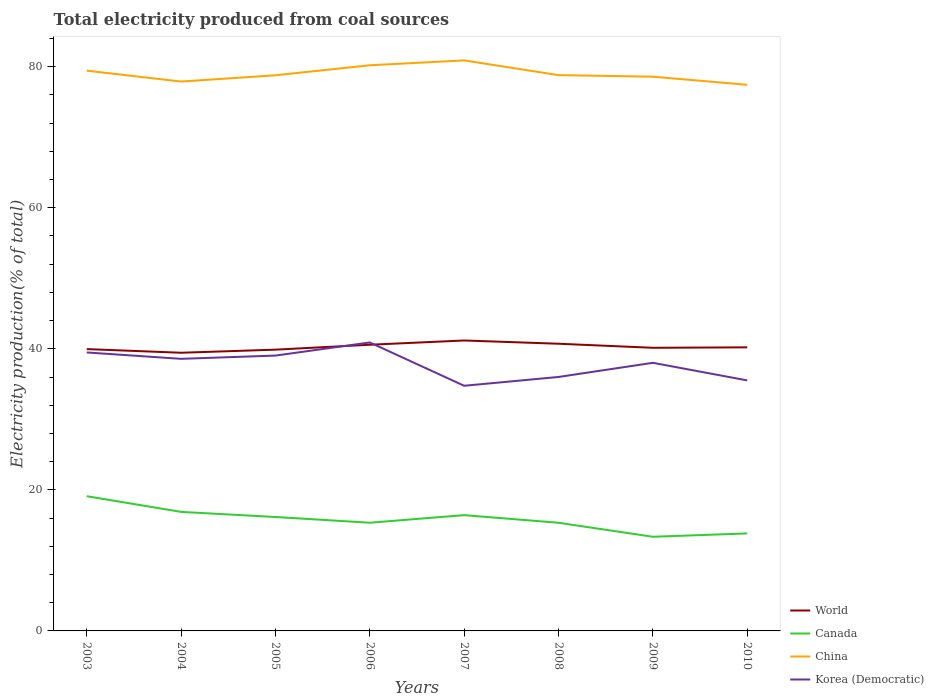Does the line corresponding to Korea (Democratic) intersect with the line corresponding to China?
Give a very brief answer. No. Is the number of lines equal to the number of legend labels?
Offer a terse response. Yes. Across all years, what is the maximum total electricity produced in China?
Your answer should be very brief. 77.44. In which year was the total electricity produced in Canada maximum?
Your answer should be very brief. 2009. What is the total total electricity produced in Canada in the graph?
Keep it short and to the point. 2.8. What is the difference between the highest and the second highest total electricity produced in Canada?
Provide a succinct answer. 5.75. What is the difference between the highest and the lowest total electricity produced in World?
Keep it short and to the point. 3. Is the total electricity produced in Korea (Democratic) strictly greater than the total electricity produced in World over the years?
Keep it short and to the point. No. How many years are there in the graph?
Your answer should be very brief. 8. Does the graph contain grids?
Your answer should be compact. No. What is the title of the graph?
Your answer should be compact. Total electricity produced from coal sources. Does "Uganda" appear as one of the legend labels in the graph?
Give a very brief answer. No. What is the label or title of the X-axis?
Your answer should be very brief. Years. What is the Electricity production(% of total) in World in 2003?
Keep it short and to the point. 39.96. What is the Electricity production(% of total) in Canada in 2003?
Give a very brief answer. 19.11. What is the Electricity production(% of total) of China in 2003?
Make the answer very short. 79.44. What is the Electricity production(% of total) in Korea (Democratic) in 2003?
Give a very brief answer. 39.49. What is the Electricity production(% of total) of World in 2004?
Your answer should be compact. 39.44. What is the Electricity production(% of total) in Canada in 2004?
Provide a succinct answer. 16.88. What is the Electricity production(% of total) of China in 2004?
Make the answer very short. 77.9. What is the Electricity production(% of total) of Korea (Democratic) in 2004?
Give a very brief answer. 38.58. What is the Electricity production(% of total) of World in 2005?
Keep it short and to the point. 39.88. What is the Electricity production(% of total) of Canada in 2005?
Give a very brief answer. 16.15. What is the Electricity production(% of total) of China in 2005?
Your response must be concise. 78.79. What is the Electricity production(% of total) in Korea (Democratic) in 2005?
Offer a terse response. 39.04. What is the Electricity production(% of total) in World in 2006?
Provide a short and direct response. 40.58. What is the Electricity production(% of total) of Canada in 2006?
Provide a succinct answer. 15.34. What is the Electricity production(% of total) in China in 2006?
Make the answer very short. 80.21. What is the Electricity production(% of total) in Korea (Democratic) in 2006?
Provide a short and direct response. 40.9. What is the Electricity production(% of total) of World in 2007?
Your response must be concise. 41.18. What is the Electricity production(% of total) of Canada in 2007?
Keep it short and to the point. 16.42. What is the Electricity production(% of total) of China in 2007?
Your answer should be very brief. 80.9. What is the Electricity production(% of total) of Korea (Democratic) in 2007?
Keep it short and to the point. 34.76. What is the Electricity production(% of total) in World in 2008?
Make the answer very short. 40.72. What is the Electricity production(% of total) in Canada in 2008?
Your response must be concise. 15.34. What is the Electricity production(% of total) in China in 2008?
Your answer should be very brief. 78.81. What is the Electricity production(% of total) in Korea (Democratic) in 2008?
Offer a terse response. 36.01. What is the Electricity production(% of total) of World in 2009?
Provide a short and direct response. 40.15. What is the Electricity production(% of total) of Canada in 2009?
Your answer should be compact. 13.35. What is the Electricity production(% of total) in China in 2009?
Make the answer very short. 78.59. What is the Electricity production(% of total) in Korea (Democratic) in 2009?
Your answer should be very brief. 38.02. What is the Electricity production(% of total) of World in 2010?
Keep it short and to the point. 40.21. What is the Electricity production(% of total) of Canada in 2010?
Keep it short and to the point. 13.83. What is the Electricity production(% of total) of China in 2010?
Keep it short and to the point. 77.44. What is the Electricity production(% of total) of Korea (Democratic) in 2010?
Offer a terse response. 35.52. Across all years, what is the maximum Electricity production(% of total) in World?
Provide a short and direct response. 41.18. Across all years, what is the maximum Electricity production(% of total) in Canada?
Offer a terse response. 19.11. Across all years, what is the maximum Electricity production(% of total) in China?
Make the answer very short. 80.9. Across all years, what is the maximum Electricity production(% of total) of Korea (Democratic)?
Offer a terse response. 40.9. Across all years, what is the minimum Electricity production(% of total) of World?
Offer a terse response. 39.44. Across all years, what is the minimum Electricity production(% of total) in Canada?
Your answer should be compact. 13.35. Across all years, what is the minimum Electricity production(% of total) of China?
Ensure brevity in your answer.  77.44. Across all years, what is the minimum Electricity production(% of total) in Korea (Democratic)?
Make the answer very short. 34.76. What is the total Electricity production(% of total) in World in the graph?
Your answer should be compact. 322.14. What is the total Electricity production(% of total) of Canada in the graph?
Provide a succinct answer. 126.41. What is the total Electricity production(% of total) of China in the graph?
Your answer should be compact. 632.09. What is the total Electricity production(% of total) in Korea (Democratic) in the graph?
Your answer should be very brief. 302.33. What is the difference between the Electricity production(% of total) of World in 2003 and that in 2004?
Give a very brief answer. 0.52. What is the difference between the Electricity production(% of total) in Canada in 2003 and that in 2004?
Offer a very short reply. 2.23. What is the difference between the Electricity production(% of total) in China in 2003 and that in 2004?
Give a very brief answer. 1.54. What is the difference between the Electricity production(% of total) in Korea (Democratic) in 2003 and that in 2004?
Provide a short and direct response. 0.91. What is the difference between the Electricity production(% of total) of World in 2003 and that in 2005?
Your answer should be compact. 0.08. What is the difference between the Electricity production(% of total) of Canada in 2003 and that in 2005?
Ensure brevity in your answer.  2.95. What is the difference between the Electricity production(% of total) in China in 2003 and that in 2005?
Ensure brevity in your answer.  0.65. What is the difference between the Electricity production(% of total) of Korea (Democratic) in 2003 and that in 2005?
Make the answer very short. 0.44. What is the difference between the Electricity production(% of total) in World in 2003 and that in 2006?
Offer a terse response. -0.62. What is the difference between the Electricity production(% of total) in Canada in 2003 and that in 2006?
Offer a terse response. 3.76. What is the difference between the Electricity production(% of total) of China in 2003 and that in 2006?
Provide a succinct answer. -0.77. What is the difference between the Electricity production(% of total) in Korea (Democratic) in 2003 and that in 2006?
Give a very brief answer. -1.42. What is the difference between the Electricity production(% of total) of World in 2003 and that in 2007?
Your answer should be very brief. -1.22. What is the difference between the Electricity production(% of total) of Canada in 2003 and that in 2007?
Keep it short and to the point. 2.69. What is the difference between the Electricity production(% of total) in China in 2003 and that in 2007?
Offer a terse response. -1.46. What is the difference between the Electricity production(% of total) in Korea (Democratic) in 2003 and that in 2007?
Make the answer very short. 4.72. What is the difference between the Electricity production(% of total) in World in 2003 and that in 2008?
Your response must be concise. -0.76. What is the difference between the Electricity production(% of total) in Canada in 2003 and that in 2008?
Keep it short and to the point. 3.77. What is the difference between the Electricity production(% of total) of China in 2003 and that in 2008?
Make the answer very short. 0.63. What is the difference between the Electricity production(% of total) in Korea (Democratic) in 2003 and that in 2008?
Offer a very short reply. 3.48. What is the difference between the Electricity production(% of total) of World in 2003 and that in 2009?
Provide a short and direct response. -0.19. What is the difference between the Electricity production(% of total) in Canada in 2003 and that in 2009?
Make the answer very short. 5.75. What is the difference between the Electricity production(% of total) of China in 2003 and that in 2009?
Ensure brevity in your answer.  0.85. What is the difference between the Electricity production(% of total) in Korea (Democratic) in 2003 and that in 2009?
Make the answer very short. 1.47. What is the difference between the Electricity production(% of total) in World in 2003 and that in 2010?
Give a very brief answer. -0.25. What is the difference between the Electricity production(% of total) of Canada in 2003 and that in 2010?
Ensure brevity in your answer.  5.28. What is the difference between the Electricity production(% of total) of China in 2003 and that in 2010?
Ensure brevity in your answer.  2. What is the difference between the Electricity production(% of total) of Korea (Democratic) in 2003 and that in 2010?
Give a very brief answer. 3.96. What is the difference between the Electricity production(% of total) in World in 2004 and that in 2005?
Ensure brevity in your answer.  -0.44. What is the difference between the Electricity production(% of total) of Canada in 2004 and that in 2005?
Your answer should be very brief. 0.73. What is the difference between the Electricity production(% of total) of China in 2004 and that in 2005?
Provide a succinct answer. -0.89. What is the difference between the Electricity production(% of total) of Korea (Democratic) in 2004 and that in 2005?
Your response must be concise. -0.46. What is the difference between the Electricity production(% of total) in World in 2004 and that in 2006?
Provide a succinct answer. -1.14. What is the difference between the Electricity production(% of total) of Canada in 2004 and that in 2006?
Offer a terse response. 1.54. What is the difference between the Electricity production(% of total) in China in 2004 and that in 2006?
Your answer should be compact. -2.31. What is the difference between the Electricity production(% of total) of Korea (Democratic) in 2004 and that in 2006?
Make the answer very short. -2.32. What is the difference between the Electricity production(% of total) in World in 2004 and that in 2007?
Ensure brevity in your answer.  -1.74. What is the difference between the Electricity production(% of total) in Canada in 2004 and that in 2007?
Make the answer very short. 0.46. What is the difference between the Electricity production(% of total) in China in 2004 and that in 2007?
Your answer should be very brief. -3. What is the difference between the Electricity production(% of total) in Korea (Democratic) in 2004 and that in 2007?
Offer a very short reply. 3.82. What is the difference between the Electricity production(% of total) of World in 2004 and that in 2008?
Offer a very short reply. -1.28. What is the difference between the Electricity production(% of total) in Canada in 2004 and that in 2008?
Your answer should be very brief. 1.54. What is the difference between the Electricity production(% of total) of China in 2004 and that in 2008?
Your response must be concise. -0.91. What is the difference between the Electricity production(% of total) in Korea (Democratic) in 2004 and that in 2008?
Offer a very short reply. 2.57. What is the difference between the Electricity production(% of total) in World in 2004 and that in 2009?
Give a very brief answer. -0.7. What is the difference between the Electricity production(% of total) of Canada in 2004 and that in 2009?
Provide a succinct answer. 3.53. What is the difference between the Electricity production(% of total) of China in 2004 and that in 2009?
Your answer should be compact. -0.69. What is the difference between the Electricity production(% of total) in Korea (Democratic) in 2004 and that in 2009?
Your response must be concise. 0.56. What is the difference between the Electricity production(% of total) of World in 2004 and that in 2010?
Offer a very short reply. -0.77. What is the difference between the Electricity production(% of total) of Canada in 2004 and that in 2010?
Give a very brief answer. 3.05. What is the difference between the Electricity production(% of total) of China in 2004 and that in 2010?
Your response must be concise. 0.46. What is the difference between the Electricity production(% of total) in Korea (Democratic) in 2004 and that in 2010?
Your answer should be very brief. 3.06. What is the difference between the Electricity production(% of total) in World in 2005 and that in 2006?
Your response must be concise. -0.7. What is the difference between the Electricity production(% of total) in Canada in 2005 and that in 2006?
Your answer should be compact. 0.81. What is the difference between the Electricity production(% of total) of China in 2005 and that in 2006?
Ensure brevity in your answer.  -1.42. What is the difference between the Electricity production(% of total) in Korea (Democratic) in 2005 and that in 2006?
Offer a very short reply. -1.86. What is the difference between the Electricity production(% of total) in World in 2005 and that in 2007?
Provide a short and direct response. -1.3. What is the difference between the Electricity production(% of total) of Canada in 2005 and that in 2007?
Your answer should be compact. -0.26. What is the difference between the Electricity production(% of total) in China in 2005 and that in 2007?
Give a very brief answer. -2.11. What is the difference between the Electricity production(% of total) of Korea (Democratic) in 2005 and that in 2007?
Make the answer very short. 4.28. What is the difference between the Electricity production(% of total) of World in 2005 and that in 2008?
Make the answer very short. -0.84. What is the difference between the Electricity production(% of total) in Canada in 2005 and that in 2008?
Offer a terse response. 0.82. What is the difference between the Electricity production(% of total) in China in 2005 and that in 2008?
Give a very brief answer. -0.02. What is the difference between the Electricity production(% of total) in Korea (Democratic) in 2005 and that in 2008?
Your answer should be very brief. 3.03. What is the difference between the Electricity production(% of total) of World in 2005 and that in 2009?
Offer a very short reply. -0.26. What is the difference between the Electricity production(% of total) in Canada in 2005 and that in 2009?
Your answer should be very brief. 2.8. What is the difference between the Electricity production(% of total) of China in 2005 and that in 2009?
Ensure brevity in your answer.  0.2. What is the difference between the Electricity production(% of total) in Korea (Democratic) in 2005 and that in 2009?
Your answer should be very brief. 1.02. What is the difference between the Electricity production(% of total) of World in 2005 and that in 2010?
Provide a succinct answer. -0.33. What is the difference between the Electricity production(% of total) in Canada in 2005 and that in 2010?
Ensure brevity in your answer.  2.33. What is the difference between the Electricity production(% of total) in China in 2005 and that in 2010?
Ensure brevity in your answer.  1.35. What is the difference between the Electricity production(% of total) in Korea (Democratic) in 2005 and that in 2010?
Provide a short and direct response. 3.52. What is the difference between the Electricity production(% of total) in World in 2006 and that in 2007?
Keep it short and to the point. -0.6. What is the difference between the Electricity production(% of total) of Canada in 2006 and that in 2007?
Keep it short and to the point. -1.07. What is the difference between the Electricity production(% of total) in China in 2006 and that in 2007?
Offer a terse response. -0.69. What is the difference between the Electricity production(% of total) of Korea (Democratic) in 2006 and that in 2007?
Your response must be concise. 6.14. What is the difference between the Electricity production(% of total) of World in 2006 and that in 2008?
Your answer should be very brief. -0.14. What is the difference between the Electricity production(% of total) in Canada in 2006 and that in 2008?
Offer a terse response. 0.01. What is the difference between the Electricity production(% of total) of China in 2006 and that in 2008?
Provide a succinct answer. 1.4. What is the difference between the Electricity production(% of total) in Korea (Democratic) in 2006 and that in 2008?
Your answer should be compact. 4.89. What is the difference between the Electricity production(% of total) in World in 2006 and that in 2009?
Keep it short and to the point. 0.43. What is the difference between the Electricity production(% of total) in Canada in 2006 and that in 2009?
Ensure brevity in your answer.  1.99. What is the difference between the Electricity production(% of total) of China in 2006 and that in 2009?
Give a very brief answer. 1.62. What is the difference between the Electricity production(% of total) in Korea (Democratic) in 2006 and that in 2009?
Keep it short and to the point. 2.88. What is the difference between the Electricity production(% of total) in World in 2006 and that in 2010?
Your response must be concise. 0.37. What is the difference between the Electricity production(% of total) in Canada in 2006 and that in 2010?
Keep it short and to the point. 1.52. What is the difference between the Electricity production(% of total) of China in 2006 and that in 2010?
Your answer should be very brief. 2.77. What is the difference between the Electricity production(% of total) in Korea (Democratic) in 2006 and that in 2010?
Ensure brevity in your answer.  5.38. What is the difference between the Electricity production(% of total) of World in 2007 and that in 2008?
Your answer should be compact. 0.46. What is the difference between the Electricity production(% of total) of Canada in 2007 and that in 2008?
Your answer should be very brief. 1.08. What is the difference between the Electricity production(% of total) in China in 2007 and that in 2008?
Offer a terse response. 2.09. What is the difference between the Electricity production(% of total) of Korea (Democratic) in 2007 and that in 2008?
Make the answer very short. -1.25. What is the difference between the Electricity production(% of total) of World in 2007 and that in 2009?
Provide a succinct answer. 1.04. What is the difference between the Electricity production(% of total) of Canada in 2007 and that in 2009?
Your answer should be very brief. 3.07. What is the difference between the Electricity production(% of total) of China in 2007 and that in 2009?
Offer a very short reply. 2.31. What is the difference between the Electricity production(% of total) in Korea (Democratic) in 2007 and that in 2009?
Offer a terse response. -3.26. What is the difference between the Electricity production(% of total) of World in 2007 and that in 2010?
Keep it short and to the point. 0.97. What is the difference between the Electricity production(% of total) of Canada in 2007 and that in 2010?
Offer a terse response. 2.59. What is the difference between the Electricity production(% of total) in China in 2007 and that in 2010?
Provide a succinct answer. 3.46. What is the difference between the Electricity production(% of total) of Korea (Democratic) in 2007 and that in 2010?
Ensure brevity in your answer.  -0.76. What is the difference between the Electricity production(% of total) in World in 2008 and that in 2009?
Give a very brief answer. 0.58. What is the difference between the Electricity production(% of total) in Canada in 2008 and that in 2009?
Your answer should be very brief. 1.99. What is the difference between the Electricity production(% of total) in China in 2008 and that in 2009?
Keep it short and to the point. 0.22. What is the difference between the Electricity production(% of total) in Korea (Democratic) in 2008 and that in 2009?
Keep it short and to the point. -2.01. What is the difference between the Electricity production(% of total) in World in 2008 and that in 2010?
Your answer should be compact. 0.51. What is the difference between the Electricity production(% of total) in Canada in 2008 and that in 2010?
Offer a very short reply. 1.51. What is the difference between the Electricity production(% of total) of China in 2008 and that in 2010?
Give a very brief answer. 1.37. What is the difference between the Electricity production(% of total) in Korea (Democratic) in 2008 and that in 2010?
Your response must be concise. 0.49. What is the difference between the Electricity production(% of total) of World in 2009 and that in 2010?
Offer a terse response. -0.06. What is the difference between the Electricity production(% of total) of Canada in 2009 and that in 2010?
Offer a very short reply. -0.47. What is the difference between the Electricity production(% of total) of China in 2009 and that in 2010?
Ensure brevity in your answer.  1.15. What is the difference between the Electricity production(% of total) of Korea (Democratic) in 2009 and that in 2010?
Provide a short and direct response. 2.5. What is the difference between the Electricity production(% of total) in World in 2003 and the Electricity production(% of total) in Canada in 2004?
Provide a short and direct response. 23.08. What is the difference between the Electricity production(% of total) of World in 2003 and the Electricity production(% of total) of China in 2004?
Make the answer very short. -37.94. What is the difference between the Electricity production(% of total) of World in 2003 and the Electricity production(% of total) of Korea (Democratic) in 2004?
Your answer should be compact. 1.38. What is the difference between the Electricity production(% of total) in Canada in 2003 and the Electricity production(% of total) in China in 2004?
Make the answer very short. -58.79. What is the difference between the Electricity production(% of total) of Canada in 2003 and the Electricity production(% of total) of Korea (Democratic) in 2004?
Your response must be concise. -19.48. What is the difference between the Electricity production(% of total) of China in 2003 and the Electricity production(% of total) of Korea (Democratic) in 2004?
Offer a terse response. 40.86. What is the difference between the Electricity production(% of total) of World in 2003 and the Electricity production(% of total) of Canada in 2005?
Keep it short and to the point. 23.81. What is the difference between the Electricity production(% of total) of World in 2003 and the Electricity production(% of total) of China in 2005?
Give a very brief answer. -38.83. What is the difference between the Electricity production(% of total) of World in 2003 and the Electricity production(% of total) of Korea (Democratic) in 2005?
Your answer should be very brief. 0.92. What is the difference between the Electricity production(% of total) of Canada in 2003 and the Electricity production(% of total) of China in 2005?
Give a very brief answer. -59.69. What is the difference between the Electricity production(% of total) in Canada in 2003 and the Electricity production(% of total) in Korea (Democratic) in 2005?
Offer a terse response. -19.94. What is the difference between the Electricity production(% of total) of China in 2003 and the Electricity production(% of total) of Korea (Democratic) in 2005?
Provide a succinct answer. 40.4. What is the difference between the Electricity production(% of total) of World in 2003 and the Electricity production(% of total) of Canada in 2006?
Ensure brevity in your answer.  24.62. What is the difference between the Electricity production(% of total) of World in 2003 and the Electricity production(% of total) of China in 2006?
Make the answer very short. -40.25. What is the difference between the Electricity production(% of total) in World in 2003 and the Electricity production(% of total) in Korea (Democratic) in 2006?
Your answer should be compact. -0.94. What is the difference between the Electricity production(% of total) in Canada in 2003 and the Electricity production(% of total) in China in 2006?
Give a very brief answer. -61.11. What is the difference between the Electricity production(% of total) of Canada in 2003 and the Electricity production(% of total) of Korea (Democratic) in 2006?
Your answer should be very brief. -21.8. What is the difference between the Electricity production(% of total) in China in 2003 and the Electricity production(% of total) in Korea (Democratic) in 2006?
Ensure brevity in your answer.  38.54. What is the difference between the Electricity production(% of total) in World in 2003 and the Electricity production(% of total) in Canada in 2007?
Provide a succinct answer. 23.55. What is the difference between the Electricity production(% of total) of World in 2003 and the Electricity production(% of total) of China in 2007?
Make the answer very short. -40.94. What is the difference between the Electricity production(% of total) in World in 2003 and the Electricity production(% of total) in Korea (Democratic) in 2007?
Keep it short and to the point. 5.2. What is the difference between the Electricity production(% of total) in Canada in 2003 and the Electricity production(% of total) in China in 2007?
Your answer should be very brief. -61.8. What is the difference between the Electricity production(% of total) of Canada in 2003 and the Electricity production(% of total) of Korea (Democratic) in 2007?
Your answer should be compact. -15.66. What is the difference between the Electricity production(% of total) of China in 2003 and the Electricity production(% of total) of Korea (Democratic) in 2007?
Your answer should be compact. 44.68. What is the difference between the Electricity production(% of total) in World in 2003 and the Electricity production(% of total) in Canada in 2008?
Your answer should be very brief. 24.63. What is the difference between the Electricity production(% of total) of World in 2003 and the Electricity production(% of total) of China in 2008?
Your response must be concise. -38.85. What is the difference between the Electricity production(% of total) in World in 2003 and the Electricity production(% of total) in Korea (Democratic) in 2008?
Provide a short and direct response. 3.95. What is the difference between the Electricity production(% of total) in Canada in 2003 and the Electricity production(% of total) in China in 2008?
Offer a terse response. -59.7. What is the difference between the Electricity production(% of total) in Canada in 2003 and the Electricity production(% of total) in Korea (Democratic) in 2008?
Give a very brief answer. -16.91. What is the difference between the Electricity production(% of total) in China in 2003 and the Electricity production(% of total) in Korea (Democratic) in 2008?
Give a very brief answer. 43.43. What is the difference between the Electricity production(% of total) of World in 2003 and the Electricity production(% of total) of Canada in 2009?
Provide a succinct answer. 26.61. What is the difference between the Electricity production(% of total) in World in 2003 and the Electricity production(% of total) in China in 2009?
Ensure brevity in your answer.  -38.63. What is the difference between the Electricity production(% of total) in World in 2003 and the Electricity production(% of total) in Korea (Democratic) in 2009?
Make the answer very short. 1.94. What is the difference between the Electricity production(% of total) in Canada in 2003 and the Electricity production(% of total) in China in 2009?
Your answer should be compact. -59.49. What is the difference between the Electricity production(% of total) in Canada in 2003 and the Electricity production(% of total) in Korea (Democratic) in 2009?
Offer a terse response. -18.91. What is the difference between the Electricity production(% of total) in China in 2003 and the Electricity production(% of total) in Korea (Democratic) in 2009?
Your answer should be very brief. 41.42. What is the difference between the Electricity production(% of total) in World in 2003 and the Electricity production(% of total) in Canada in 2010?
Offer a very short reply. 26.14. What is the difference between the Electricity production(% of total) of World in 2003 and the Electricity production(% of total) of China in 2010?
Offer a terse response. -37.48. What is the difference between the Electricity production(% of total) in World in 2003 and the Electricity production(% of total) in Korea (Democratic) in 2010?
Ensure brevity in your answer.  4.44. What is the difference between the Electricity production(% of total) of Canada in 2003 and the Electricity production(% of total) of China in 2010?
Keep it short and to the point. -58.33. What is the difference between the Electricity production(% of total) in Canada in 2003 and the Electricity production(% of total) in Korea (Democratic) in 2010?
Provide a succinct answer. -16.42. What is the difference between the Electricity production(% of total) of China in 2003 and the Electricity production(% of total) of Korea (Democratic) in 2010?
Keep it short and to the point. 43.92. What is the difference between the Electricity production(% of total) of World in 2004 and the Electricity production(% of total) of Canada in 2005?
Provide a succinct answer. 23.29. What is the difference between the Electricity production(% of total) of World in 2004 and the Electricity production(% of total) of China in 2005?
Give a very brief answer. -39.35. What is the difference between the Electricity production(% of total) of World in 2004 and the Electricity production(% of total) of Korea (Democratic) in 2005?
Your answer should be very brief. 0.4. What is the difference between the Electricity production(% of total) in Canada in 2004 and the Electricity production(% of total) in China in 2005?
Provide a short and direct response. -61.91. What is the difference between the Electricity production(% of total) of Canada in 2004 and the Electricity production(% of total) of Korea (Democratic) in 2005?
Offer a terse response. -22.16. What is the difference between the Electricity production(% of total) of China in 2004 and the Electricity production(% of total) of Korea (Democratic) in 2005?
Your response must be concise. 38.86. What is the difference between the Electricity production(% of total) of World in 2004 and the Electricity production(% of total) of Canada in 2006?
Offer a very short reply. 24.1. What is the difference between the Electricity production(% of total) in World in 2004 and the Electricity production(% of total) in China in 2006?
Your response must be concise. -40.77. What is the difference between the Electricity production(% of total) in World in 2004 and the Electricity production(% of total) in Korea (Democratic) in 2006?
Make the answer very short. -1.46. What is the difference between the Electricity production(% of total) of Canada in 2004 and the Electricity production(% of total) of China in 2006?
Your answer should be compact. -63.33. What is the difference between the Electricity production(% of total) in Canada in 2004 and the Electricity production(% of total) in Korea (Democratic) in 2006?
Your response must be concise. -24.02. What is the difference between the Electricity production(% of total) of China in 2004 and the Electricity production(% of total) of Korea (Democratic) in 2006?
Provide a succinct answer. 37. What is the difference between the Electricity production(% of total) of World in 2004 and the Electricity production(% of total) of Canada in 2007?
Provide a short and direct response. 23.03. What is the difference between the Electricity production(% of total) of World in 2004 and the Electricity production(% of total) of China in 2007?
Make the answer very short. -41.46. What is the difference between the Electricity production(% of total) in World in 2004 and the Electricity production(% of total) in Korea (Democratic) in 2007?
Offer a very short reply. 4.68. What is the difference between the Electricity production(% of total) of Canada in 2004 and the Electricity production(% of total) of China in 2007?
Ensure brevity in your answer.  -64.02. What is the difference between the Electricity production(% of total) in Canada in 2004 and the Electricity production(% of total) in Korea (Democratic) in 2007?
Your response must be concise. -17.88. What is the difference between the Electricity production(% of total) of China in 2004 and the Electricity production(% of total) of Korea (Democratic) in 2007?
Your response must be concise. 43.14. What is the difference between the Electricity production(% of total) of World in 2004 and the Electricity production(% of total) of Canada in 2008?
Keep it short and to the point. 24.11. What is the difference between the Electricity production(% of total) of World in 2004 and the Electricity production(% of total) of China in 2008?
Keep it short and to the point. -39.37. What is the difference between the Electricity production(% of total) of World in 2004 and the Electricity production(% of total) of Korea (Democratic) in 2008?
Keep it short and to the point. 3.43. What is the difference between the Electricity production(% of total) of Canada in 2004 and the Electricity production(% of total) of China in 2008?
Your response must be concise. -61.93. What is the difference between the Electricity production(% of total) of Canada in 2004 and the Electricity production(% of total) of Korea (Democratic) in 2008?
Ensure brevity in your answer.  -19.13. What is the difference between the Electricity production(% of total) in China in 2004 and the Electricity production(% of total) in Korea (Democratic) in 2008?
Your response must be concise. 41.89. What is the difference between the Electricity production(% of total) in World in 2004 and the Electricity production(% of total) in Canada in 2009?
Provide a short and direct response. 26.09. What is the difference between the Electricity production(% of total) in World in 2004 and the Electricity production(% of total) in China in 2009?
Offer a terse response. -39.15. What is the difference between the Electricity production(% of total) of World in 2004 and the Electricity production(% of total) of Korea (Democratic) in 2009?
Your answer should be very brief. 1.43. What is the difference between the Electricity production(% of total) in Canada in 2004 and the Electricity production(% of total) in China in 2009?
Keep it short and to the point. -61.71. What is the difference between the Electricity production(% of total) in Canada in 2004 and the Electricity production(% of total) in Korea (Democratic) in 2009?
Your answer should be compact. -21.14. What is the difference between the Electricity production(% of total) of China in 2004 and the Electricity production(% of total) of Korea (Democratic) in 2009?
Your response must be concise. 39.88. What is the difference between the Electricity production(% of total) in World in 2004 and the Electricity production(% of total) in Canada in 2010?
Your answer should be very brief. 25.62. What is the difference between the Electricity production(% of total) of World in 2004 and the Electricity production(% of total) of China in 2010?
Your response must be concise. -38. What is the difference between the Electricity production(% of total) in World in 2004 and the Electricity production(% of total) in Korea (Democratic) in 2010?
Ensure brevity in your answer.  3.92. What is the difference between the Electricity production(% of total) in Canada in 2004 and the Electricity production(% of total) in China in 2010?
Offer a terse response. -60.56. What is the difference between the Electricity production(% of total) of Canada in 2004 and the Electricity production(% of total) of Korea (Democratic) in 2010?
Offer a very short reply. -18.64. What is the difference between the Electricity production(% of total) of China in 2004 and the Electricity production(% of total) of Korea (Democratic) in 2010?
Provide a short and direct response. 42.38. What is the difference between the Electricity production(% of total) of World in 2005 and the Electricity production(% of total) of Canada in 2006?
Your answer should be very brief. 24.54. What is the difference between the Electricity production(% of total) of World in 2005 and the Electricity production(% of total) of China in 2006?
Offer a very short reply. -40.33. What is the difference between the Electricity production(% of total) in World in 2005 and the Electricity production(% of total) in Korea (Democratic) in 2006?
Provide a short and direct response. -1.02. What is the difference between the Electricity production(% of total) in Canada in 2005 and the Electricity production(% of total) in China in 2006?
Provide a succinct answer. -64.06. What is the difference between the Electricity production(% of total) in Canada in 2005 and the Electricity production(% of total) in Korea (Democratic) in 2006?
Your response must be concise. -24.75. What is the difference between the Electricity production(% of total) in China in 2005 and the Electricity production(% of total) in Korea (Democratic) in 2006?
Make the answer very short. 37.89. What is the difference between the Electricity production(% of total) of World in 2005 and the Electricity production(% of total) of Canada in 2007?
Offer a terse response. 23.47. What is the difference between the Electricity production(% of total) in World in 2005 and the Electricity production(% of total) in China in 2007?
Ensure brevity in your answer.  -41.02. What is the difference between the Electricity production(% of total) in World in 2005 and the Electricity production(% of total) in Korea (Democratic) in 2007?
Make the answer very short. 5.12. What is the difference between the Electricity production(% of total) of Canada in 2005 and the Electricity production(% of total) of China in 2007?
Make the answer very short. -64.75. What is the difference between the Electricity production(% of total) in Canada in 2005 and the Electricity production(% of total) in Korea (Democratic) in 2007?
Offer a very short reply. -18.61. What is the difference between the Electricity production(% of total) in China in 2005 and the Electricity production(% of total) in Korea (Democratic) in 2007?
Ensure brevity in your answer.  44.03. What is the difference between the Electricity production(% of total) in World in 2005 and the Electricity production(% of total) in Canada in 2008?
Give a very brief answer. 24.55. What is the difference between the Electricity production(% of total) of World in 2005 and the Electricity production(% of total) of China in 2008?
Make the answer very short. -38.93. What is the difference between the Electricity production(% of total) in World in 2005 and the Electricity production(% of total) in Korea (Democratic) in 2008?
Offer a terse response. 3.87. What is the difference between the Electricity production(% of total) of Canada in 2005 and the Electricity production(% of total) of China in 2008?
Provide a short and direct response. -62.66. What is the difference between the Electricity production(% of total) of Canada in 2005 and the Electricity production(% of total) of Korea (Democratic) in 2008?
Offer a terse response. -19.86. What is the difference between the Electricity production(% of total) in China in 2005 and the Electricity production(% of total) in Korea (Democratic) in 2008?
Keep it short and to the point. 42.78. What is the difference between the Electricity production(% of total) of World in 2005 and the Electricity production(% of total) of Canada in 2009?
Provide a short and direct response. 26.53. What is the difference between the Electricity production(% of total) in World in 2005 and the Electricity production(% of total) in China in 2009?
Ensure brevity in your answer.  -38.71. What is the difference between the Electricity production(% of total) of World in 2005 and the Electricity production(% of total) of Korea (Democratic) in 2009?
Provide a short and direct response. 1.87. What is the difference between the Electricity production(% of total) of Canada in 2005 and the Electricity production(% of total) of China in 2009?
Offer a terse response. -62.44. What is the difference between the Electricity production(% of total) in Canada in 2005 and the Electricity production(% of total) in Korea (Democratic) in 2009?
Your answer should be very brief. -21.87. What is the difference between the Electricity production(% of total) in China in 2005 and the Electricity production(% of total) in Korea (Democratic) in 2009?
Provide a succinct answer. 40.77. What is the difference between the Electricity production(% of total) in World in 2005 and the Electricity production(% of total) in Canada in 2010?
Make the answer very short. 26.06. What is the difference between the Electricity production(% of total) in World in 2005 and the Electricity production(% of total) in China in 2010?
Make the answer very short. -37.56. What is the difference between the Electricity production(% of total) of World in 2005 and the Electricity production(% of total) of Korea (Democratic) in 2010?
Provide a short and direct response. 4.36. What is the difference between the Electricity production(% of total) of Canada in 2005 and the Electricity production(% of total) of China in 2010?
Offer a terse response. -61.29. What is the difference between the Electricity production(% of total) in Canada in 2005 and the Electricity production(% of total) in Korea (Democratic) in 2010?
Ensure brevity in your answer.  -19.37. What is the difference between the Electricity production(% of total) in China in 2005 and the Electricity production(% of total) in Korea (Democratic) in 2010?
Your response must be concise. 43.27. What is the difference between the Electricity production(% of total) in World in 2006 and the Electricity production(% of total) in Canada in 2007?
Your answer should be compact. 24.16. What is the difference between the Electricity production(% of total) of World in 2006 and the Electricity production(% of total) of China in 2007?
Make the answer very short. -40.32. What is the difference between the Electricity production(% of total) of World in 2006 and the Electricity production(% of total) of Korea (Democratic) in 2007?
Keep it short and to the point. 5.82. What is the difference between the Electricity production(% of total) of Canada in 2006 and the Electricity production(% of total) of China in 2007?
Provide a short and direct response. -65.56. What is the difference between the Electricity production(% of total) of Canada in 2006 and the Electricity production(% of total) of Korea (Democratic) in 2007?
Keep it short and to the point. -19.42. What is the difference between the Electricity production(% of total) in China in 2006 and the Electricity production(% of total) in Korea (Democratic) in 2007?
Your answer should be very brief. 45.45. What is the difference between the Electricity production(% of total) in World in 2006 and the Electricity production(% of total) in Canada in 2008?
Keep it short and to the point. 25.24. What is the difference between the Electricity production(% of total) of World in 2006 and the Electricity production(% of total) of China in 2008?
Provide a short and direct response. -38.23. What is the difference between the Electricity production(% of total) of World in 2006 and the Electricity production(% of total) of Korea (Democratic) in 2008?
Offer a very short reply. 4.57. What is the difference between the Electricity production(% of total) of Canada in 2006 and the Electricity production(% of total) of China in 2008?
Make the answer very short. -63.47. What is the difference between the Electricity production(% of total) of Canada in 2006 and the Electricity production(% of total) of Korea (Democratic) in 2008?
Offer a very short reply. -20.67. What is the difference between the Electricity production(% of total) of China in 2006 and the Electricity production(% of total) of Korea (Democratic) in 2008?
Make the answer very short. 44.2. What is the difference between the Electricity production(% of total) of World in 2006 and the Electricity production(% of total) of Canada in 2009?
Make the answer very short. 27.23. What is the difference between the Electricity production(% of total) of World in 2006 and the Electricity production(% of total) of China in 2009?
Offer a terse response. -38.01. What is the difference between the Electricity production(% of total) of World in 2006 and the Electricity production(% of total) of Korea (Democratic) in 2009?
Ensure brevity in your answer.  2.56. What is the difference between the Electricity production(% of total) in Canada in 2006 and the Electricity production(% of total) in China in 2009?
Offer a terse response. -63.25. What is the difference between the Electricity production(% of total) in Canada in 2006 and the Electricity production(% of total) in Korea (Democratic) in 2009?
Your answer should be very brief. -22.68. What is the difference between the Electricity production(% of total) in China in 2006 and the Electricity production(% of total) in Korea (Democratic) in 2009?
Ensure brevity in your answer.  42.19. What is the difference between the Electricity production(% of total) in World in 2006 and the Electricity production(% of total) in Canada in 2010?
Ensure brevity in your answer.  26.76. What is the difference between the Electricity production(% of total) in World in 2006 and the Electricity production(% of total) in China in 2010?
Offer a terse response. -36.86. What is the difference between the Electricity production(% of total) of World in 2006 and the Electricity production(% of total) of Korea (Democratic) in 2010?
Provide a short and direct response. 5.06. What is the difference between the Electricity production(% of total) of Canada in 2006 and the Electricity production(% of total) of China in 2010?
Ensure brevity in your answer.  -62.1. What is the difference between the Electricity production(% of total) in Canada in 2006 and the Electricity production(% of total) in Korea (Democratic) in 2010?
Ensure brevity in your answer.  -20.18. What is the difference between the Electricity production(% of total) of China in 2006 and the Electricity production(% of total) of Korea (Democratic) in 2010?
Your response must be concise. 44.69. What is the difference between the Electricity production(% of total) of World in 2007 and the Electricity production(% of total) of Canada in 2008?
Provide a short and direct response. 25.85. What is the difference between the Electricity production(% of total) of World in 2007 and the Electricity production(% of total) of China in 2008?
Provide a succinct answer. -37.62. What is the difference between the Electricity production(% of total) of World in 2007 and the Electricity production(% of total) of Korea (Democratic) in 2008?
Your answer should be compact. 5.17. What is the difference between the Electricity production(% of total) of Canada in 2007 and the Electricity production(% of total) of China in 2008?
Keep it short and to the point. -62.39. What is the difference between the Electricity production(% of total) of Canada in 2007 and the Electricity production(% of total) of Korea (Democratic) in 2008?
Provide a succinct answer. -19.59. What is the difference between the Electricity production(% of total) of China in 2007 and the Electricity production(% of total) of Korea (Democratic) in 2008?
Provide a short and direct response. 44.89. What is the difference between the Electricity production(% of total) of World in 2007 and the Electricity production(% of total) of Canada in 2009?
Give a very brief answer. 27.83. What is the difference between the Electricity production(% of total) in World in 2007 and the Electricity production(% of total) in China in 2009?
Your answer should be very brief. -37.41. What is the difference between the Electricity production(% of total) of World in 2007 and the Electricity production(% of total) of Korea (Democratic) in 2009?
Give a very brief answer. 3.17. What is the difference between the Electricity production(% of total) of Canada in 2007 and the Electricity production(% of total) of China in 2009?
Provide a succinct answer. -62.17. What is the difference between the Electricity production(% of total) in Canada in 2007 and the Electricity production(% of total) in Korea (Democratic) in 2009?
Offer a terse response. -21.6. What is the difference between the Electricity production(% of total) in China in 2007 and the Electricity production(% of total) in Korea (Democratic) in 2009?
Provide a succinct answer. 42.88. What is the difference between the Electricity production(% of total) of World in 2007 and the Electricity production(% of total) of Canada in 2010?
Provide a short and direct response. 27.36. What is the difference between the Electricity production(% of total) in World in 2007 and the Electricity production(% of total) in China in 2010?
Give a very brief answer. -36.25. What is the difference between the Electricity production(% of total) in World in 2007 and the Electricity production(% of total) in Korea (Democratic) in 2010?
Your answer should be very brief. 5.66. What is the difference between the Electricity production(% of total) in Canada in 2007 and the Electricity production(% of total) in China in 2010?
Provide a succinct answer. -61.02. What is the difference between the Electricity production(% of total) in Canada in 2007 and the Electricity production(% of total) in Korea (Democratic) in 2010?
Your answer should be compact. -19.11. What is the difference between the Electricity production(% of total) in China in 2007 and the Electricity production(% of total) in Korea (Democratic) in 2010?
Your response must be concise. 45.38. What is the difference between the Electricity production(% of total) of World in 2008 and the Electricity production(% of total) of Canada in 2009?
Your answer should be compact. 27.37. What is the difference between the Electricity production(% of total) in World in 2008 and the Electricity production(% of total) in China in 2009?
Your answer should be compact. -37.87. What is the difference between the Electricity production(% of total) in World in 2008 and the Electricity production(% of total) in Korea (Democratic) in 2009?
Provide a succinct answer. 2.71. What is the difference between the Electricity production(% of total) of Canada in 2008 and the Electricity production(% of total) of China in 2009?
Give a very brief answer. -63.25. What is the difference between the Electricity production(% of total) in Canada in 2008 and the Electricity production(% of total) in Korea (Democratic) in 2009?
Give a very brief answer. -22.68. What is the difference between the Electricity production(% of total) in China in 2008 and the Electricity production(% of total) in Korea (Democratic) in 2009?
Make the answer very short. 40.79. What is the difference between the Electricity production(% of total) of World in 2008 and the Electricity production(% of total) of Canada in 2010?
Give a very brief answer. 26.9. What is the difference between the Electricity production(% of total) of World in 2008 and the Electricity production(% of total) of China in 2010?
Keep it short and to the point. -36.72. What is the difference between the Electricity production(% of total) in World in 2008 and the Electricity production(% of total) in Korea (Democratic) in 2010?
Offer a very short reply. 5.2. What is the difference between the Electricity production(% of total) in Canada in 2008 and the Electricity production(% of total) in China in 2010?
Offer a very short reply. -62.1. What is the difference between the Electricity production(% of total) in Canada in 2008 and the Electricity production(% of total) in Korea (Democratic) in 2010?
Provide a succinct answer. -20.19. What is the difference between the Electricity production(% of total) of China in 2008 and the Electricity production(% of total) of Korea (Democratic) in 2010?
Your response must be concise. 43.29. What is the difference between the Electricity production(% of total) in World in 2009 and the Electricity production(% of total) in Canada in 2010?
Keep it short and to the point. 26.32. What is the difference between the Electricity production(% of total) in World in 2009 and the Electricity production(% of total) in China in 2010?
Keep it short and to the point. -37.29. What is the difference between the Electricity production(% of total) in World in 2009 and the Electricity production(% of total) in Korea (Democratic) in 2010?
Offer a very short reply. 4.63. What is the difference between the Electricity production(% of total) in Canada in 2009 and the Electricity production(% of total) in China in 2010?
Give a very brief answer. -64.09. What is the difference between the Electricity production(% of total) in Canada in 2009 and the Electricity production(% of total) in Korea (Democratic) in 2010?
Your answer should be compact. -22.17. What is the difference between the Electricity production(% of total) of China in 2009 and the Electricity production(% of total) of Korea (Democratic) in 2010?
Give a very brief answer. 43.07. What is the average Electricity production(% of total) in World per year?
Keep it short and to the point. 40.27. What is the average Electricity production(% of total) of Canada per year?
Make the answer very short. 15.8. What is the average Electricity production(% of total) of China per year?
Your response must be concise. 79.01. What is the average Electricity production(% of total) of Korea (Democratic) per year?
Your answer should be compact. 37.79. In the year 2003, what is the difference between the Electricity production(% of total) of World and Electricity production(% of total) of Canada?
Your answer should be compact. 20.86. In the year 2003, what is the difference between the Electricity production(% of total) of World and Electricity production(% of total) of China?
Give a very brief answer. -39.48. In the year 2003, what is the difference between the Electricity production(% of total) of World and Electricity production(% of total) of Korea (Democratic)?
Your answer should be compact. 0.47. In the year 2003, what is the difference between the Electricity production(% of total) of Canada and Electricity production(% of total) of China?
Your answer should be very brief. -60.34. In the year 2003, what is the difference between the Electricity production(% of total) in Canada and Electricity production(% of total) in Korea (Democratic)?
Your answer should be compact. -20.38. In the year 2003, what is the difference between the Electricity production(% of total) in China and Electricity production(% of total) in Korea (Democratic)?
Make the answer very short. 39.96. In the year 2004, what is the difference between the Electricity production(% of total) of World and Electricity production(% of total) of Canada?
Provide a succinct answer. 22.56. In the year 2004, what is the difference between the Electricity production(% of total) of World and Electricity production(% of total) of China?
Offer a terse response. -38.46. In the year 2004, what is the difference between the Electricity production(% of total) in World and Electricity production(% of total) in Korea (Democratic)?
Keep it short and to the point. 0.86. In the year 2004, what is the difference between the Electricity production(% of total) of Canada and Electricity production(% of total) of China?
Keep it short and to the point. -61.02. In the year 2004, what is the difference between the Electricity production(% of total) in Canada and Electricity production(% of total) in Korea (Democratic)?
Make the answer very short. -21.7. In the year 2004, what is the difference between the Electricity production(% of total) in China and Electricity production(% of total) in Korea (Democratic)?
Offer a very short reply. 39.32. In the year 2005, what is the difference between the Electricity production(% of total) of World and Electricity production(% of total) of Canada?
Give a very brief answer. 23.73. In the year 2005, what is the difference between the Electricity production(% of total) in World and Electricity production(% of total) in China?
Make the answer very short. -38.91. In the year 2005, what is the difference between the Electricity production(% of total) of World and Electricity production(% of total) of Korea (Democratic)?
Your answer should be compact. 0.84. In the year 2005, what is the difference between the Electricity production(% of total) of Canada and Electricity production(% of total) of China?
Your answer should be compact. -62.64. In the year 2005, what is the difference between the Electricity production(% of total) in Canada and Electricity production(% of total) in Korea (Democratic)?
Your answer should be compact. -22.89. In the year 2005, what is the difference between the Electricity production(% of total) in China and Electricity production(% of total) in Korea (Democratic)?
Provide a succinct answer. 39.75. In the year 2006, what is the difference between the Electricity production(% of total) of World and Electricity production(% of total) of Canada?
Offer a terse response. 25.24. In the year 2006, what is the difference between the Electricity production(% of total) of World and Electricity production(% of total) of China?
Offer a very short reply. -39.63. In the year 2006, what is the difference between the Electricity production(% of total) in World and Electricity production(% of total) in Korea (Democratic)?
Make the answer very short. -0.32. In the year 2006, what is the difference between the Electricity production(% of total) of Canada and Electricity production(% of total) of China?
Offer a very short reply. -64.87. In the year 2006, what is the difference between the Electricity production(% of total) in Canada and Electricity production(% of total) in Korea (Democratic)?
Provide a succinct answer. -25.56. In the year 2006, what is the difference between the Electricity production(% of total) of China and Electricity production(% of total) of Korea (Democratic)?
Your answer should be very brief. 39.31. In the year 2007, what is the difference between the Electricity production(% of total) in World and Electricity production(% of total) in Canada?
Your answer should be very brief. 24.77. In the year 2007, what is the difference between the Electricity production(% of total) of World and Electricity production(% of total) of China?
Your response must be concise. -39.72. In the year 2007, what is the difference between the Electricity production(% of total) of World and Electricity production(% of total) of Korea (Democratic)?
Your answer should be very brief. 6.42. In the year 2007, what is the difference between the Electricity production(% of total) in Canada and Electricity production(% of total) in China?
Make the answer very short. -64.48. In the year 2007, what is the difference between the Electricity production(% of total) in Canada and Electricity production(% of total) in Korea (Democratic)?
Make the answer very short. -18.35. In the year 2007, what is the difference between the Electricity production(% of total) in China and Electricity production(% of total) in Korea (Democratic)?
Ensure brevity in your answer.  46.14. In the year 2008, what is the difference between the Electricity production(% of total) in World and Electricity production(% of total) in Canada?
Provide a succinct answer. 25.39. In the year 2008, what is the difference between the Electricity production(% of total) in World and Electricity production(% of total) in China?
Provide a short and direct response. -38.09. In the year 2008, what is the difference between the Electricity production(% of total) in World and Electricity production(% of total) in Korea (Democratic)?
Your answer should be compact. 4.71. In the year 2008, what is the difference between the Electricity production(% of total) of Canada and Electricity production(% of total) of China?
Your answer should be compact. -63.47. In the year 2008, what is the difference between the Electricity production(% of total) of Canada and Electricity production(% of total) of Korea (Democratic)?
Offer a terse response. -20.68. In the year 2008, what is the difference between the Electricity production(% of total) in China and Electricity production(% of total) in Korea (Democratic)?
Provide a succinct answer. 42.8. In the year 2009, what is the difference between the Electricity production(% of total) in World and Electricity production(% of total) in Canada?
Offer a terse response. 26.8. In the year 2009, what is the difference between the Electricity production(% of total) of World and Electricity production(% of total) of China?
Give a very brief answer. -38.44. In the year 2009, what is the difference between the Electricity production(% of total) in World and Electricity production(% of total) in Korea (Democratic)?
Your answer should be very brief. 2.13. In the year 2009, what is the difference between the Electricity production(% of total) in Canada and Electricity production(% of total) in China?
Your answer should be very brief. -65.24. In the year 2009, what is the difference between the Electricity production(% of total) in Canada and Electricity production(% of total) in Korea (Democratic)?
Provide a succinct answer. -24.67. In the year 2009, what is the difference between the Electricity production(% of total) in China and Electricity production(% of total) in Korea (Democratic)?
Give a very brief answer. 40.57. In the year 2010, what is the difference between the Electricity production(% of total) of World and Electricity production(% of total) of Canada?
Offer a terse response. 26.39. In the year 2010, what is the difference between the Electricity production(% of total) in World and Electricity production(% of total) in China?
Ensure brevity in your answer.  -37.23. In the year 2010, what is the difference between the Electricity production(% of total) of World and Electricity production(% of total) of Korea (Democratic)?
Make the answer very short. 4.69. In the year 2010, what is the difference between the Electricity production(% of total) in Canada and Electricity production(% of total) in China?
Offer a very short reply. -63.61. In the year 2010, what is the difference between the Electricity production(% of total) of Canada and Electricity production(% of total) of Korea (Democratic)?
Your response must be concise. -21.7. In the year 2010, what is the difference between the Electricity production(% of total) in China and Electricity production(% of total) in Korea (Democratic)?
Make the answer very short. 41.92. What is the ratio of the Electricity production(% of total) in World in 2003 to that in 2004?
Offer a very short reply. 1.01. What is the ratio of the Electricity production(% of total) of Canada in 2003 to that in 2004?
Keep it short and to the point. 1.13. What is the ratio of the Electricity production(% of total) of China in 2003 to that in 2004?
Ensure brevity in your answer.  1.02. What is the ratio of the Electricity production(% of total) in Korea (Democratic) in 2003 to that in 2004?
Your answer should be very brief. 1.02. What is the ratio of the Electricity production(% of total) of World in 2003 to that in 2005?
Your response must be concise. 1. What is the ratio of the Electricity production(% of total) in Canada in 2003 to that in 2005?
Provide a short and direct response. 1.18. What is the ratio of the Electricity production(% of total) in China in 2003 to that in 2005?
Offer a terse response. 1.01. What is the ratio of the Electricity production(% of total) in Korea (Democratic) in 2003 to that in 2005?
Your answer should be compact. 1.01. What is the ratio of the Electricity production(% of total) of World in 2003 to that in 2006?
Offer a terse response. 0.98. What is the ratio of the Electricity production(% of total) in Canada in 2003 to that in 2006?
Your answer should be compact. 1.25. What is the ratio of the Electricity production(% of total) in China in 2003 to that in 2006?
Provide a short and direct response. 0.99. What is the ratio of the Electricity production(% of total) in Korea (Democratic) in 2003 to that in 2006?
Your answer should be very brief. 0.97. What is the ratio of the Electricity production(% of total) in World in 2003 to that in 2007?
Provide a succinct answer. 0.97. What is the ratio of the Electricity production(% of total) of Canada in 2003 to that in 2007?
Offer a terse response. 1.16. What is the ratio of the Electricity production(% of total) in Korea (Democratic) in 2003 to that in 2007?
Ensure brevity in your answer.  1.14. What is the ratio of the Electricity production(% of total) in World in 2003 to that in 2008?
Provide a short and direct response. 0.98. What is the ratio of the Electricity production(% of total) in Canada in 2003 to that in 2008?
Provide a succinct answer. 1.25. What is the ratio of the Electricity production(% of total) of China in 2003 to that in 2008?
Your answer should be very brief. 1.01. What is the ratio of the Electricity production(% of total) in Korea (Democratic) in 2003 to that in 2008?
Keep it short and to the point. 1.1. What is the ratio of the Electricity production(% of total) of Canada in 2003 to that in 2009?
Offer a terse response. 1.43. What is the ratio of the Electricity production(% of total) in China in 2003 to that in 2009?
Your answer should be very brief. 1.01. What is the ratio of the Electricity production(% of total) of Korea (Democratic) in 2003 to that in 2009?
Ensure brevity in your answer.  1.04. What is the ratio of the Electricity production(% of total) in Canada in 2003 to that in 2010?
Provide a succinct answer. 1.38. What is the ratio of the Electricity production(% of total) in China in 2003 to that in 2010?
Offer a very short reply. 1.03. What is the ratio of the Electricity production(% of total) in Korea (Democratic) in 2003 to that in 2010?
Give a very brief answer. 1.11. What is the ratio of the Electricity production(% of total) of World in 2004 to that in 2005?
Make the answer very short. 0.99. What is the ratio of the Electricity production(% of total) of Canada in 2004 to that in 2005?
Give a very brief answer. 1.04. What is the ratio of the Electricity production(% of total) in China in 2004 to that in 2005?
Offer a very short reply. 0.99. What is the ratio of the Electricity production(% of total) of Canada in 2004 to that in 2006?
Your answer should be compact. 1.1. What is the ratio of the Electricity production(% of total) in China in 2004 to that in 2006?
Make the answer very short. 0.97. What is the ratio of the Electricity production(% of total) of Korea (Democratic) in 2004 to that in 2006?
Provide a succinct answer. 0.94. What is the ratio of the Electricity production(% of total) of World in 2004 to that in 2007?
Give a very brief answer. 0.96. What is the ratio of the Electricity production(% of total) in Canada in 2004 to that in 2007?
Make the answer very short. 1.03. What is the ratio of the Electricity production(% of total) in China in 2004 to that in 2007?
Your answer should be very brief. 0.96. What is the ratio of the Electricity production(% of total) in Korea (Democratic) in 2004 to that in 2007?
Offer a very short reply. 1.11. What is the ratio of the Electricity production(% of total) in World in 2004 to that in 2008?
Your answer should be very brief. 0.97. What is the ratio of the Electricity production(% of total) of Canada in 2004 to that in 2008?
Your response must be concise. 1.1. What is the ratio of the Electricity production(% of total) in Korea (Democratic) in 2004 to that in 2008?
Give a very brief answer. 1.07. What is the ratio of the Electricity production(% of total) in World in 2004 to that in 2009?
Give a very brief answer. 0.98. What is the ratio of the Electricity production(% of total) in Canada in 2004 to that in 2009?
Your answer should be compact. 1.26. What is the ratio of the Electricity production(% of total) of China in 2004 to that in 2009?
Offer a terse response. 0.99. What is the ratio of the Electricity production(% of total) of Korea (Democratic) in 2004 to that in 2009?
Make the answer very short. 1.01. What is the ratio of the Electricity production(% of total) of World in 2004 to that in 2010?
Offer a very short reply. 0.98. What is the ratio of the Electricity production(% of total) of Canada in 2004 to that in 2010?
Offer a terse response. 1.22. What is the ratio of the Electricity production(% of total) of China in 2004 to that in 2010?
Offer a very short reply. 1.01. What is the ratio of the Electricity production(% of total) of Korea (Democratic) in 2004 to that in 2010?
Your response must be concise. 1.09. What is the ratio of the Electricity production(% of total) in World in 2005 to that in 2006?
Offer a terse response. 0.98. What is the ratio of the Electricity production(% of total) of Canada in 2005 to that in 2006?
Your answer should be compact. 1.05. What is the ratio of the Electricity production(% of total) in China in 2005 to that in 2006?
Give a very brief answer. 0.98. What is the ratio of the Electricity production(% of total) in Korea (Democratic) in 2005 to that in 2006?
Give a very brief answer. 0.95. What is the ratio of the Electricity production(% of total) of World in 2005 to that in 2007?
Provide a short and direct response. 0.97. What is the ratio of the Electricity production(% of total) in Canada in 2005 to that in 2007?
Ensure brevity in your answer.  0.98. What is the ratio of the Electricity production(% of total) in China in 2005 to that in 2007?
Give a very brief answer. 0.97. What is the ratio of the Electricity production(% of total) in Korea (Democratic) in 2005 to that in 2007?
Offer a very short reply. 1.12. What is the ratio of the Electricity production(% of total) of World in 2005 to that in 2008?
Give a very brief answer. 0.98. What is the ratio of the Electricity production(% of total) in Canada in 2005 to that in 2008?
Keep it short and to the point. 1.05. What is the ratio of the Electricity production(% of total) in Korea (Democratic) in 2005 to that in 2008?
Your answer should be compact. 1.08. What is the ratio of the Electricity production(% of total) in Canada in 2005 to that in 2009?
Your answer should be compact. 1.21. What is the ratio of the Electricity production(% of total) in China in 2005 to that in 2009?
Your answer should be very brief. 1. What is the ratio of the Electricity production(% of total) in Korea (Democratic) in 2005 to that in 2009?
Your answer should be compact. 1.03. What is the ratio of the Electricity production(% of total) in Canada in 2005 to that in 2010?
Your answer should be very brief. 1.17. What is the ratio of the Electricity production(% of total) of China in 2005 to that in 2010?
Provide a succinct answer. 1.02. What is the ratio of the Electricity production(% of total) of Korea (Democratic) in 2005 to that in 2010?
Offer a terse response. 1.1. What is the ratio of the Electricity production(% of total) of Canada in 2006 to that in 2007?
Your answer should be very brief. 0.93. What is the ratio of the Electricity production(% of total) in Korea (Democratic) in 2006 to that in 2007?
Your answer should be very brief. 1.18. What is the ratio of the Electricity production(% of total) of World in 2006 to that in 2008?
Ensure brevity in your answer.  1. What is the ratio of the Electricity production(% of total) of China in 2006 to that in 2008?
Make the answer very short. 1.02. What is the ratio of the Electricity production(% of total) of Korea (Democratic) in 2006 to that in 2008?
Give a very brief answer. 1.14. What is the ratio of the Electricity production(% of total) of World in 2006 to that in 2009?
Ensure brevity in your answer.  1.01. What is the ratio of the Electricity production(% of total) in Canada in 2006 to that in 2009?
Offer a very short reply. 1.15. What is the ratio of the Electricity production(% of total) of China in 2006 to that in 2009?
Ensure brevity in your answer.  1.02. What is the ratio of the Electricity production(% of total) of Korea (Democratic) in 2006 to that in 2009?
Your answer should be compact. 1.08. What is the ratio of the Electricity production(% of total) in World in 2006 to that in 2010?
Provide a short and direct response. 1.01. What is the ratio of the Electricity production(% of total) of Canada in 2006 to that in 2010?
Offer a very short reply. 1.11. What is the ratio of the Electricity production(% of total) in China in 2006 to that in 2010?
Offer a terse response. 1.04. What is the ratio of the Electricity production(% of total) in Korea (Democratic) in 2006 to that in 2010?
Give a very brief answer. 1.15. What is the ratio of the Electricity production(% of total) of World in 2007 to that in 2008?
Provide a succinct answer. 1.01. What is the ratio of the Electricity production(% of total) in Canada in 2007 to that in 2008?
Your answer should be very brief. 1.07. What is the ratio of the Electricity production(% of total) in China in 2007 to that in 2008?
Make the answer very short. 1.03. What is the ratio of the Electricity production(% of total) in Korea (Democratic) in 2007 to that in 2008?
Your answer should be compact. 0.97. What is the ratio of the Electricity production(% of total) of World in 2007 to that in 2009?
Provide a short and direct response. 1.03. What is the ratio of the Electricity production(% of total) in Canada in 2007 to that in 2009?
Your answer should be very brief. 1.23. What is the ratio of the Electricity production(% of total) in China in 2007 to that in 2009?
Your answer should be compact. 1.03. What is the ratio of the Electricity production(% of total) of Korea (Democratic) in 2007 to that in 2009?
Keep it short and to the point. 0.91. What is the ratio of the Electricity production(% of total) in World in 2007 to that in 2010?
Give a very brief answer. 1.02. What is the ratio of the Electricity production(% of total) in Canada in 2007 to that in 2010?
Offer a terse response. 1.19. What is the ratio of the Electricity production(% of total) in China in 2007 to that in 2010?
Ensure brevity in your answer.  1.04. What is the ratio of the Electricity production(% of total) of Korea (Democratic) in 2007 to that in 2010?
Your answer should be very brief. 0.98. What is the ratio of the Electricity production(% of total) of World in 2008 to that in 2009?
Give a very brief answer. 1.01. What is the ratio of the Electricity production(% of total) of Canada in 2008 to that in 2009?
Offer a very short reply. 1.15. What is the ratio of the Electricity production(% of total) in China in 2008 to that in 2009?
Keep it short and to the point. 1. What is the ratio of the Electricity production(% of total) in Korea (Democratic) in 2008 to that in 2009?
Provide a succinct answer. 0.95. What is the ratio of the Electricity production(% of total) in World in 2008 to that in 2010?
Offer a terse response. 1.01. What is the ratio of the Electricity production(% of total) of Canada in 2008 to that in 2010?
Keep it short and to the point. 1.11. What is the ratio of the Electricity production(% of total) of China in 2008 to that in 2010?
Provide a short and direct response. 1.02. What is the ratio of the Electricity production(% of total) in Korea (Democratic) in 2008 to that in 2010?
Provide a succinct answer. 1.01. What is the ratio of the Electricity production(% of total) of World in 2009 to that in 2010?
Make the answer very short. 1. What is the ratio of the Electricity production(% of total) of Canada in 2009 to that in 2010?
Your answer should be very brief. 0.97. What is the ratio of the Electricity production(% of total) of China in 2009 to that in 2010?
Your answer should be very brief. 1.01. What is the ratio of the Electricity production(% of total) in Korea (Democratic) in 2009 to that in 2010?
Ensure brevity in your answer.  1.07. What is the difference between the highest and the second highest Electricity production(% of total) of World?
Ensure brevity in your answer.  0.46. What is the difference between the highest and the second highest Electricity production(% of total) of Canada?
Your answer should be compact. 2.23. What is the difference between the highest and the second highest Electricity production(% of total) in China?
Keep it short and to the point. 0.69. What is the difference between the highest and the second highest Electricity production(% of total) of Korea (Democratic)?
Provide a short and direct response. 1.42. What is the difference between the highest and the lowest Electricity production(% of total) in World?
Ensure brevity in your answer.  1.74. What is the difference between the highest and the lowest Electricity production(% of total) in Canada?
Your response must be concise. 5.75. What is the difference between the highest and the lowest Electricity production(% of total) of China?
Make the answer very short. 3.46. What is the difference between the highest and the lowest Electricity production(% of total) in Korea (Democratic)?
Make the answer very short. 6.14. 